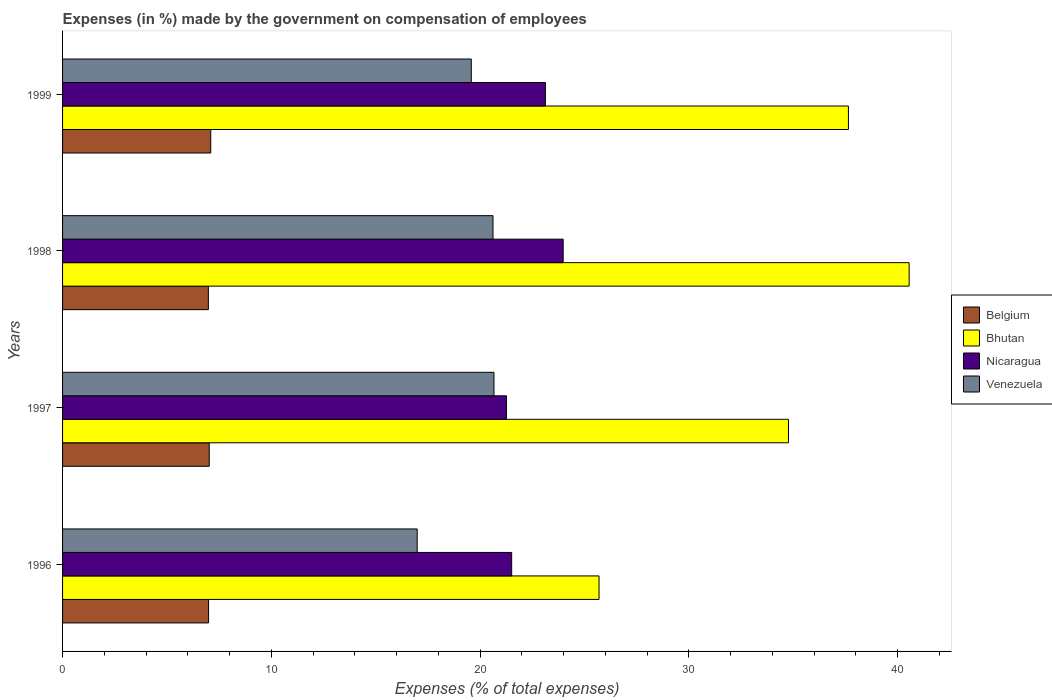How many different coloured bars are there?
Offer a very short reply. 4. How many groups of bars are there?
Your response must be concise. 4. Are the number of bars on each tick of the Y-axis equal?
Make the answer very short. Yes. How many bars are there on the 3rd tick from the bottom?
Offer a terse response. 4. What is the label of the 4th group of bars from the top?
Keep it short and to the point. 1996. What is the percentage of expenses made by the government on compensation of employees in Bhutan in 1998?
Offer a terse response. 40.56. Across all years, what is the maximum percentage of expenses made by the government on compensation of employees in Venezuela?
Keep it short and to the point. 20.67. Across all years, what is the minimum percentage of expenses made by the government on compensation of employees in Venezuela?
Make the answer very short. 16.99. In which year was the percentage of expenses made by the government on compensation of employees in Nicaragua maximum?
Provide a succinct answer. 1998. In which year was the percentage of expenses made by the government on compensation of employees in Nicaragua minimum?
Offer a very short reply. 1997. What is the total percentage of expenses made by the government on compensation of employees in Venezuela in the graph?
Your answer should be compact. 77.85. What is the difference between the percentage of expenses made by the government on compensation of employees in Bhutan in 1996 and that in 1997?
Ensure brevity in your answer.  -9.07. What is the difference between the percentage of expenses made by the government on compensation of employees in Bhutan in 1996 and the percentage of expenses made by the government on compensation of employees in Nicaragua in 1999?
Ensure brevity in your answer.  2.57. What is the average percentage of expenses made by the government on compensation of employees in Venezuela per year?
Your answer should be very brief. 19.46. In the year 1999, what is the difference between the percentage of expenses made by the government on compensation of employees in Bhutan and percentage of expenses made by the government on compensation of employees in Nicaragua?
Your answer should be very brief. 14.51. In how many years, is the percentage of expenses made by the government on compensation of employees in Venezuela greater than 4 %?
Your answer should be very brief. 4. What is the ratio of the percentage of expenses made by the government on compensation of employees in Nicaragua in 1996 to that in 1997?
Your answer should be very brief. 1.01. Is the percentage of expenses made by the government on compensation of employees in Belgium in 1997 less than that in 1998?
Your answer should be very brief. No. Is the difference between the percentage of expenses made by the government on compensation of employees in Bhutan in 1997 and 1999 greater than the difference between the percentage of expenses made by the government on compensation of employees in Nicaragua in 1997 and 1999?
Provide a succinct answer. No. What is the difference between the highest and the second highest percentage of expenses made by the government on compensation of employees in Bhutan?
Keep it short and to the point. 2.91. What is the difference between the highest and the lowest percentage of expenses made by the government on compensation of employees in Bhutan?
Offer a very short reply. 14.86. In how many years, is the percentage of expenses made by the government on compensation of employees in Venezuela greater than the average percentage of expenses made by the government on compensation of employees in Venezuela taken over all years?
Provide a succinct answer. 3. Is it the case that in every year, the sum of the percentage of expenses made by the government on compensation of employees in Bhutan and percentage of expenses made by the government on compensation of employees in Belgium is greater than the sum of percentage of expenses made by the government on compensation of employees in Nicaragua and percentage of expenses made by the government on compensation of employees in Venezuela?
Offer a very short reply. No. What does the 4th bar from the top in 1996 represents?
Give a very brief answer. Belgium. What does the 4th bar from the bottom in 1998 represents?
Provide a succinct answer. Venezuela. Is it the case that in every year, the sum of the percentage of expenses made by the government on compensation of employees in Belgium and percentage of expenses made by the government on compensation of employees in Venezuela is greater than the percentage of expenses made by the government on compensation of employees in Bhutan?
Your response must be concise. No. How many years are there in the graph?
Your answer should be compact. 4. What is the difference between two consecutive major ticks on the X-axis?
Give a very brief answer. 10. Does the graph contain grids?
Ensure brevity in your answer.  No. Where does the legend appear in the graph?
Your answer should be very brief. Center right. How many legend labels are there?
Offer a very short reply. 4. How are the legend labels stacked?
Give a very brief answer. Vertical. What is the title of the graph?
Your response must be concise. Expenses (in %) made by the government on compensation of employees. Does "Finland" appear as one of the legend labels in the graph?
Your answer should be very brief. No. What is the label or title of the X-axis?
Your answer should be very brief. Expenses (% of total expenses). What is the Expenses (% of total expenses) of Belgium in 1996?
Give a very brief answer. 6.99. What is the Expenses (% of total expenses) in Bhutan in 1996?
Give a very brief answer. 25.7. What is the Expenses (% of total expenses) in Nicaragua in 1996?
Make the answer very short. 21.51. What is the Expenses (% of total expenses) in Venezuela in 1996?
Keep it short and to the point. 16.99. What is the Expenses (% of total expenses) of Belgium in 1997?
Provide a succinct answer. 7.03. What is the Expenses (% of total expenses) in Bhutan in 1997?
Provide a short and direct response. 34.77. What is the Expenses (% of total expenses) of Nicaragua in 1997?
Keep it short and to the point. 21.26. What is the Expenses (% of total expenses) in Venezuela in 1997?
Your response must be concise. 20.67. What is the Expenses (% of total expenses) of Belgium in 1998?
Your answer should be compact. 6.98. What is the Expenses (% of total expenses) in Bhutan in 1998?
Make the answer very short. 40.56. What is the Expenses (% of total expenses) in Nicaragua in 1998?
Provide a succinct answer. 23.98. What is the Expenses (% of total expenses) of Venezuela in 1998?
Provide a short and direct response. 20.62. What is the Expenses (% of total expenses) in Belgium in 1999?
Ensure brevity in your answer.  7.1. What is the Expenses (% of total expenses) of Bhutan in 1999?
Provide a short and direct response. 37.65. What is the Expenses (% of total expenses) in Nicaragua in 1999?
Provide a short and direct response. 23.13. What is the Expenses (% of total expenses) of Venezuela in 1999?
Your answer should be compact. 19.58. Across all years, what is the maximum Expenses (% of total expenses) in Belgium?
Offer a terse response. 7.1. Across all years, what is the maximum Expenses (% of total expenses) in Bhutan?
Your answer should be very brief. 40.56. Across all years, what is the maximum Expenses (% of total expenses) in Nicaragua?
Provide a short and direct response. 23.98. Across all years, what is the maximum Expenses (% of total expenses) of Venezuela?
Offer a very short reply. 20.67. Across all years, what is the minimum Expenses (% of total expenses) of Belgium?
Keep it short and to the point. 6.98. Across all years, what is the minimum Expenses (% of total expenses) in Bhutan?
Your response must be concise. 25.7. Across all years, what is the minimum Expenses (% of total expenses) in Nicaragua?
Provide a succinct answer. 21.26. Across all years, what is the minimum Expenses (% of total expenses) of Venezuela?
Your answer should be compact. 16.99. What is the total Expenses (% of total expenses) of Belgium in the graph?
Give a very brief answer. 28.1. What is the total Expenses (% of total expenses) of Bhutan in the graph?
Offer a very short reply. 138.67. What is the total Expenses (% of total expenses) of Nicaragua in the graph?
Keep it short and to the point. 89.89. What is the total Expenses (% of total expenses) of Venezuela in the graph?
Provide a succinct answer. 77.85. What is the difference between the Expenses (% of total expenses) in Belgium in 1996 and that in 1997?
Your answer should be compact. -0.03. What is the difference between the Expenses (% of total expenses) of Bhutan in 1996 and that in 1997?
Your response must be concise. -9.07. What is the difference between the Expenses (% of total expenses) in Nicaragua in 1996 and that in 1997?
Ensure brevity in your answer.  0.25. What is the difference between the Expenses (% of total expenses) of Venezuela in 1996 and that in 1997?
Provide a short and direct response. -3.68. What is the difference between the Expenses (% of total expenses) of Belgium in 1996 and that in 1998?
Make the answer very short. 0.01. What is the difference between the Expenses (% of total expenses) in Bhutan in 1996 and that in 1998?
Make the answer very short. -14.86. What is the difference between the Expenses (% of total expenses) of Nicaragua in 1996 and that in 1998?
Ensure brevity in your answer.  -2.47. What is the difference between the Expenses (% of total expenses) of Venezuela in 1996 and that in 1998?
Offer a terse response. -3.63. What is the difference between the Expenses (% of total expenses) of Belgium in 1996 and that in 1999?
Offer a very short reply. -0.1. What is the difference between the Expenses (% of total expenses) in Bhutan in 1996 and that in 1999?
Offer a very short reply. -11.95. What is the difference between the Expenses (% of total expenses) of Nicaragua in 1996 and that in 1999?
Your response must be concise. -1.62. What is the difference between the Expenses (% of total expenses) of Venezuela in 1996 and that in 1999?
Your answer should be very brief. -2.59. What is the difference between the Expenses (% of total expenses) of Belgium in 1997 and that in 1998?
Ensure brevity in your answer.  0.04. What is the difference between the Expenses (% of total expenses) in Bhutan in 1997 and that in 1998?
Keep it short and to the point. -5.78. What is the difference between the Expenses (% of total expenses) of Nicaragua in 1997 and that in 1998?
Your response must be concise. -2.72. What is the difference between the Expenses (% of total expenses) in Venezuela in 1997 and that in 1998?
Your response must be concise. 0.05. What is the difference between the Expenses (% of total expenses) in Belgium in 1997 and that in 1999?
Your answer should be compact. -0.07. What is the difference between the Expenses (% of total expenses) of Bhutan in 1997 and that in 1999?
Provide a succinct answer. -2.87. What is the difference between the Expenses (% of total expenses) of Nicaragua in 1997 and that in 1999?
Provide a succinct answer. -1.87. What is the difference between the Expenses (% of total expenses) in Venezuela in 1997 and that in 1999?
Make the answer very short. 1.09. What is the difference between the Expenses (% of total expenses) in Belgium in 1998 and that in 1999?
Provide a short and direct response. -0.11. What is the difference between the Expenses (% of total expenses) of Bhutan in 1998 and that in 1999?
Ensure brevity in your answer.  2.91. What is the difference between the Expenses (% of total expenses) in Nicaragua in 1998 and that in 1999?
Make the answer very short. 0.85. What is the difference between the Expenses (% of total expenses) of Venezuela in 1998 and that in 1999?
Provide a succinct answer. 1.04. What is the difference between the Expenses (% of total expenses) of Belgium in 1996 and the Expenses (% of total expenses) of Bhutan in 1997?
Provide a succinct answer. -27.78. What is the difference between the Expenses (% of total expenses) in Belgium in 1996 and the Expenses (% of total expenses) in Nicaragua in 1997?
Provide a short and direct response. -14.27. What is the difference between the Expenses (% of total expenses) of Belgium in 1996 and the Expenses (% of total expenses) of Venezuela in 1997?
Keep it short and to the point. -13.67. What is the difference between the Expenses (% of total expenses) of Bhutan in 1996 and the Expenses (% of total expenses) of Nicaragua in 1997?
Make the answer very short. 4.44. What is the difference between the Expenses (% of total expenses) in Bhutan in 1996 and the Expenses (% of total expenses) in Venezuela in 1997?
Offer a very short reply. 5.03. What is the difference between the Expenses (% of total expenses) in Nicaragua in 1996 and the Expenses (% of total expenses) in Venezuela in 1997?
Give a very brief answer. 0.85. What is the difference between the Expenses (% of total expenses) of Belgium in 1996 and the Expenses (% of total expenses) of Bhutan in 1998?
Provide a short and direct response. -33.56. What is the difference between the Expenses (% of total expenses) of Belgium in 1996 and the Expenses (% of total expenses) of Nicaragua in 1998?
Your response must be concise. -16.99. What is the difference between the Expenses (% of total expenses) of Belgium in 1996 and the Expenses (% of total expenses) of Venezuela in 1998?
Provide a succinct answer. -13.63. What is the difference between the Expenses (% of total expenses) in Bhutan in 1996 and the Expenses (% of total expenses) in Nicaragua in 1998?
Keep it short and to the point. 1.72. What is the difference between the Expenses (% of total expenses) of Bhutan in 1996 and the Expenses (% of total expenses) of Venezuela in 1998?
Offer a very short reply. 5.08. What is the difference between the Expenses (% of total expenses) of Nicaragua in 1996 and the Expenses (% of total expenses) of Venezuela in 1998?
Ensure brevity in your answer.  0.89. What is the difference between the Expenses (% of total expenses) in Belgium in 1996 and the Expenses (% of total expenses) in Bhutan in 1999?
Your answer should be compact. -30.65. What is the difference between the Expenses (% of total expenses) of Belgium in 1996 and the Expenses (% of total expenses) of Nicaragua in 1999?
Offer a very short reply. -16.14. What is the difference between the Expenses (% of total expenses) in Belgium in 1996 and the Expenses (% of total expenses) in Venezuela in 1999?
Your response must be concise. -12.58. What is the difference between the Expenses (% of total expenses) in Bhutan in 1996 and the Expenses (% of total expenses) in Nicaragua in 1999?
Your answer should be compact. 2.57. What is the difference between the Expenses (% of total expenses) in Bhutan in 1996 and the Expenses (% of total expenses) in Venezuela in 1999?
Provide a succinct answer. 6.12. What is the difference between the Expenses (% of total expenses) of Nicaragua in 1996 and the Expenses (% of total expenses) of Venezuela in 1999?
Your answer should be very brief. 1.93. What is the difference between the Expenses (% of total expenses) of Belgium in 1997 and the Expenses (% of total expenses) of Bhutan in 1998?
Your response must be concise. -33.53. What is the difference between the Expenses (% of total expenses) in Belgium in 1997 and the Expenses (% of total expenses) in Nicaragua in 1998?
Offer a terse response. -16.95. What is the difference between the Expenses (% of total expenses) in Belgium in 1997 and the Expenses (% of total expenses) in Venezuela in 1998?
Make the answer very short. -13.59. What is the difference between the Expenses (% of total expenses) in Bhutan in 1997 and the Expenses (% of total expenses) in Nicaragua in 1998?
Your answer should be very brief. 10.79. What is the difference between the Expenses (% of total expenses) of Bhutan in 1997 and the Expenses (% of total expenses) of Venezuela in 1998?
Keep it short and to the point. 14.15. What is the difference between the Expenses (% of total expenses) of Nicaragua in 1997 and the Expenses (% of total expenses) of Venezuela in 1998?
Offer a very short reply. 0.64. What is the difference between the Expenses (% of total expenses) of Belgium in 1997 and the Expenses (% of total expenses) of Bhutan in 1999?
Make the answer very short. -30.62. What is the difference between the Expenses (% of total expenses) of Belgium in 1997 and the Expenses (% of total expenses) of Nicaragua in 1999?
Provide a succinct answer. -16.11. What is the difference between the Expenses (% of total expenses) of Belgium in 1997 and the Expenses (% of total expenses) of Venezuela in 1999?
Ensure brevity in your answer.  -12.55. What is the difference between the Expenses (% of total expenses) in Bhutan in 1997 and the Expenses (% of total expenses) in Nicaragua in 1999?
Your answer should be compact. 11.64. What is the difference between the Expenses (% of total expenses) of Bhutan in 1997 and the Expenses (% of total expenses) of Venezuela in 1999?
Provide a succinct answer. 15.19. What is the difference between the Expenses (% of total expenses) in Nicaragua in 1997 and the Expenses (% of total expenses) in Venezuela in 1999?
Offer a very short reply. 1.69. What is the difference between the Expenses (% of total expenses) in Belgium in 1998 and the Expenses (% of total expenses) in Bhutan in 1999?
Offer a very short reply. -30.66. What is the difference between the Expenses (% of total expenses) in Belgium in 1998 and the Expenses (% of total expenses) in Nicaragua in 1999?
Keep it short and to the point. -16.15. What is the difference between the Expenses (% of total expenses) in Belgium in 1998 and the Expenses (% of total expenses) in Venezuela in 1999?
Offer a very short reply. -12.59. What is the difference between the Expenses (% of total expenses) in Bhutan in 1998 and the Expenses (% of total expenses) in Nicaragua in 1999?
Your answer should be very brief. 17.42. What is the difference between the Expenses (% of total expenses) of Bhutan in 1998 and the Expenses (% of total expenses) of Venezuela in 1999?
Your answer should be compact. 20.98. What is the difference between the Expenses (% of total expenses) in Nicaragua in 1998 and the Expenses (% of total expenses) in Venezuela in 1999?
Your answer should be very brief. 4.4. What is the average Expenses (% of total expenses) in Belgium per year?
Provide a short and direct response. 7.03. What is the average Expenses (% of total expenses) in Bhutan per year?
Give a very brief answer. 34.67. What is the average Expenses (% of total expenses) in Nicaragua per year?
Keep it short and to the point. 22.47. What is the average Expenses (% of total expenses) in Venezuela per year?
Give a very brief answer. 19.46. In the year 1996, what is the difference between the Expenses (% of total expenses) of Belgium and Expenses (% of total expenses) of Bhutan?
Your answer should be very brief. -18.71. In the year 1996, what is the difference between the Expenses (% of total expenses) in Belgium and Expenses (% of total expenses) in Nicaragua?
Your answer should be compact. -14.52. In the year 1996, what is the difference between the Expenses (% of total expenses) in Belgium and Expenses (% of total expenses) in Venezuela?
Your response must be concise. -9.99. In the year 1996, what is the difference between the Expenses (% of total expenses) in Bhutan and Expenses (% of total expenses) in Nicaragua?
Provide a short and direct response. 4.19. In the year 1996, what is the difference between the Expenses (% of total expenses) of Bhutan and Expenses (% of total expenses) of Venezuela?
Provide a short and direct response. 8.71. In the year 1996, what is the difference between the Expenses (% of total expenses) in Nicaragua and Expenses (% of total expenses) in Venezuela?
Provide a succinct answer. 4.53. In the year 1997, what is the difference between the Expenses (% of total expenses) in Belgium and Expenses (% of total expenses) in Bhutan?
Offer a terse response. -27.75. In the year 1997, what is the difference between the Expenses (% of total expenses) of Belgium and Expenses (% of total expenses) of Nicaragua?
Make the answer very short. -14.24. In the year 1997, what is the difference between the Expenses (% of total expenses) of Belgium and Expenses (% of total expenses) of Venezuela?
Your answer should be very brief. -13.64. In the year 1997, what is the difference between the Expenses (% of total expenses) in Bhutan and Expenses (% of total expenses) in Nicaragua?
Your answer should be compact. 13.51. In the year 1997, what is the difference between the Expenses (% of total expenses) of Bhutan and Expenses (% of total expenses) of Venezuela?
Keep it short and to the point. 14.11. In the year 1997, what is the difference between the Expenses (% of total expenses) in Nicaragua and Expenses (% of total expenses) in Venezuela?
Your answer should be very brief. 0.6. In the year 1998, what is the difference between the Expenses (% of total expenses) in Belgium and Expenses (% of total expenses) in Bhutan?
Ensure brevity in your answer.  -33.57. In the year 1998, what is the difference between the Expenses (% of total expenses) of Belgium and Expenses (% of total expenses) of Nicaragua?
Make the answer very short. -17. In the year 1998, what is the difference between the Expenses (% of total expenses) in Belgium and Expenses (% of total expenses) in Venezuela?
Provide a succinct answer. -13.63. In the year 1998, what is the difference between the Expenses (% of total expenses) in Bhutan and Expenses (% of total expenses) in Nicaragua?
Your answer should be very brief. 16.57. In the year 1998, what is the difference between the Expenses (% of total expenses) of Bhutan and Expenses (% of total expenses) of Venezuela?
Make the answer very short. 19.94. In the year 1998, what is the difference between the Expenses (% of total expenses) of Nicaragua and Expenses (% of total expenses) of Venezuela?
Your answer should be compact. 3.36. In the year 1999, what is the difference between the Expenses (% of total expenses) of Belgium and Expenses (% of total expenses) of Bhutan?
Ensure brevity in your answer.  -30.55. In the year 1999, what is the difference between the Expenses (% of total expenses) of Belgium and Expenses (% of total expenses) of Nicaragua?
Offer a terse response. -16.03. In the year 1999, what is the difference between the Expenses (% of total expenses) of Belgium and Expenses (% of total expenses) of Venezuela?
Keep it short and to the point. -12.48. In the year 1999, what is the difference between the Expenses (% of total expenses) in Bhutan and Expenses (% of total expenses) in Nicaragua?
Make the answer very short. 14.51. In the year 1999, what is the difference between the Expenses (% of total expenses) in Bhutan and Expenses (% of total expenses) in Venezuela?
Provide a succinct answer. 18.07. In the year 1999, what is the difference between the Expenses (% of total expenses) in Nicaragua and Expenses (% of total expenses) in Venezuela?
Offer a very short reply. 3.55. What is the ratio of the Expenses (% of total expenses) of Belgium in 1996 to that in 1997?
Your response must be concise. 1. What is the ratio of the Expenses (% of total expenses) in Bhutan in 1996 to that in 1997?
Give a very brief answer. 0.74. What is the ratio of the Expenses (% of total expenses) of Nicaragua in 1996 to that in 1997?
Your response must be concise. 1.01. What is the ratio of the Expenses (% of total expenses) in Venezuela in 1996 to that in 1997?
Ensure brevity in your answer.  0.82. What is the ratio of the Expenses (% of total expenses) of Bhutan in 1996 to that in 1998?
Your answer should be compact. 0.63. What is the ratio of the Expenses (% of total expenses) of Nicaragua in 1996 to that in 1998?
Give a very brief answer. 0.9. What is the ratio of the Expenses (% of total expenses) of Venezuela in 1996 to that in 1998?
Your answer should be compact. 0.82. What is the ratio of the Expenses (% of total expenses) in Belgium in 1996 to that in 1999?
Offer a very short reply. 0.99. What is the ratio of the Expenses (% of total expenses) of Bhutan in 1996 to that in 1999?
Offer a very short reply. 0.68. What is the ratio of the Expenses (% of total expenses) of Nicaragua in 1996 to that in 1999?
Ensure brevity in your answer.  0.93. What is the ratio of the Expenses (% of total expenses) of Venezuela in 1996 to that in 1999?
Give a very brief answer. 0.87. What is the ratio of the Expenses (% of total expenses) of Belgium in 1997 to that in 1998?
Keep it short and to the point. 1.01. What is the ratio of the Expenses (% of total expenses) of Bhutan in 1997 to that in 1998?
Provide a succinct answer. 0.86. What is the ratio of the Expenses (% of total expenses) of Nicaragua in 1997 to that in 1998?
Make the answer very short. 0.89. What is the ratio of the Expenses (% of total expenses) of Bhutan in 1997 to that in 1999?
Your answer should be very brief. 0.92. What is the ratio of the Expenses (% of total expenses) in Nicaragua in 1997 to that in 1999?
Your response must be concise. 0.92. What is the ratio of the Expenses (% of total expenses) of Venezuela in 1997 to that in 1999?
Provide a short and direct response. 1.06. What is the ratio of the Expenses (% of total expenses) in Belgium in 1998 to that in 1999?
Give a very brief answer. 0.98. What is the ratio of the Expenses (% of total expenses) of Bhutan in 1998 to that in 1999?
Offer a terse response. 1.08. What is the ratio of the Expenses (% of total expenses) in Nicaragua in 1998 to that in 1999?
Keep it short and to the point. 1.04. What is the ratio of the Expenses (% of total expenses) of Venezuela in 1998 to that in 1999?
Provide a short and direct response. 1.05. What is the difference between the highest and the second highest Expenses (% of total expenses) of Belgium?
Ensure brevity in your answer.  0.07. What is the difference between the highest and the second highest Expenses (% of total expenses) of Bhutan?
Your answer should be compact. 2.91. What is the difference between the highest and the second highest Expenses (% of total expenses) of Nicaragua?
Make the answer very short. 0.85. What is the difference between the highest and the second highest Expenses (% of total expenses) in Venezuela?
Keep it short and to the point. 0.05. What is the difference between the highest and the lowest Expenses (% of total expenses) in Belgium?
Give a very brief answer. 0.11. What is the difference between the highest and the lowest Expenses (% of total expenses) of Bhutan?
Keep it short and to the point. 14.86. What is the difference between the highest and the lowest Expenses (% of total expenses) of Nicaragua?
Your answer should be compact. 2.72. What is the difference between the highest and the lowest Expenses (% of total expenses) of Venezuela?
Keep it short and to the point. 3.68. 